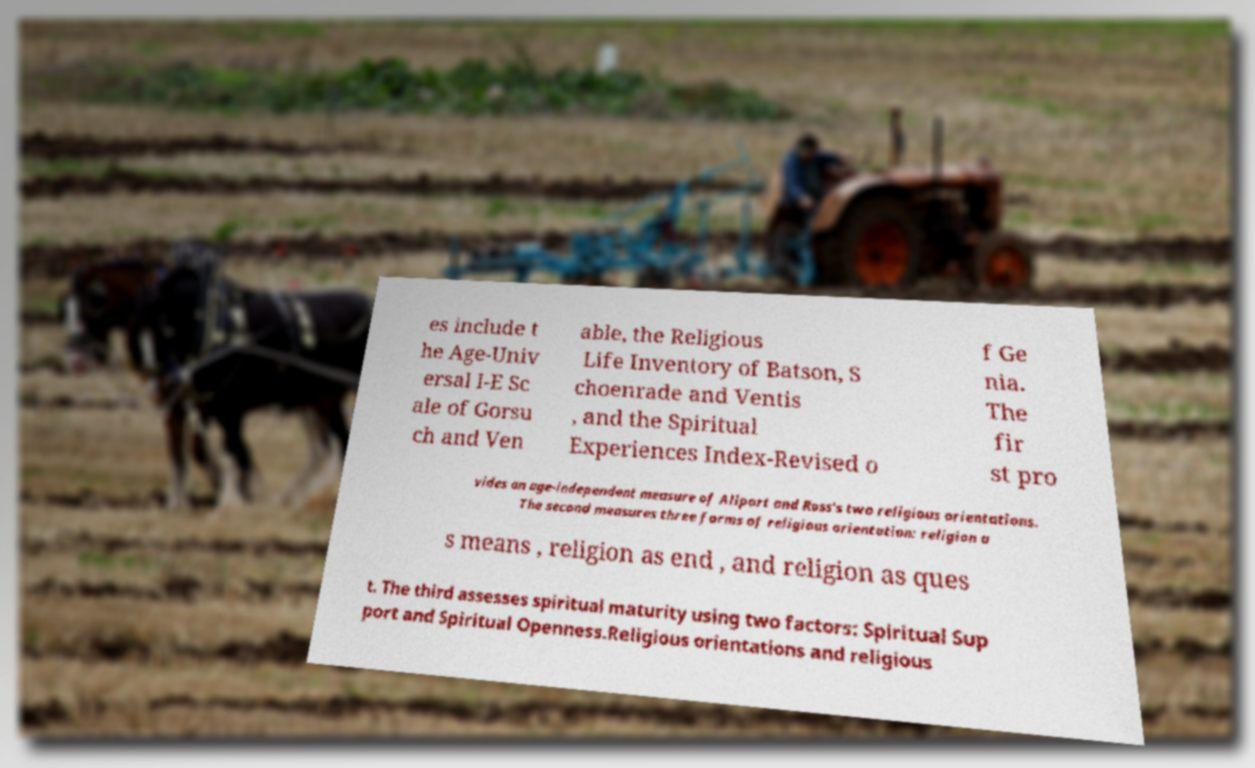For documentation purposes, I need the text within this image transcribed. Could you provide that? es include t he Age-Univ ersal I-E Sc ale of Gorsu ch and Ven able, the Religious Life Inventory of Batson, S choenrade and Ventis , and the Spiritual Experiences Index-Revised o f Ge nia. The fir st pro vides an age-independent measure of Allport and Ross's two religious orientations. The second measures three forms of religious orientation: religion a s means , religion as end , and religion as ques t. The third assesses spiritual maturity using two factors: Spiritual Sup port and Spiritual Openness.Religious orientations and religious 